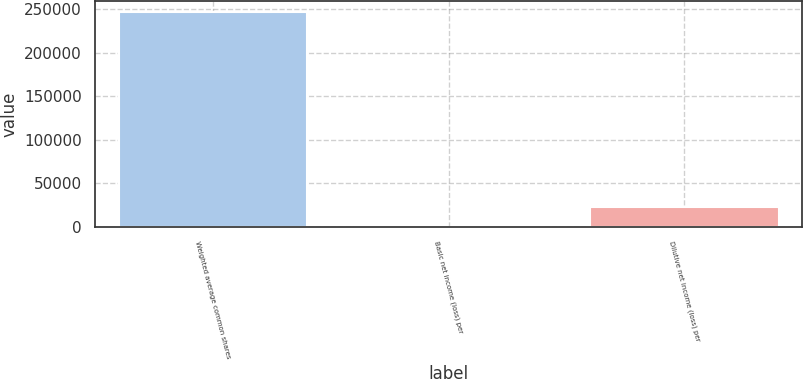<chart> <loc_0><loc_0><loc_500><loc_500><bar_chart><fcel>Weighted average common shares<fcel>Basic net income (loss) per<fcel>Dilutive net income (loss) per<nl><fcel>246769<fcel>1.14<fcel>22434.6<nl></chart> 